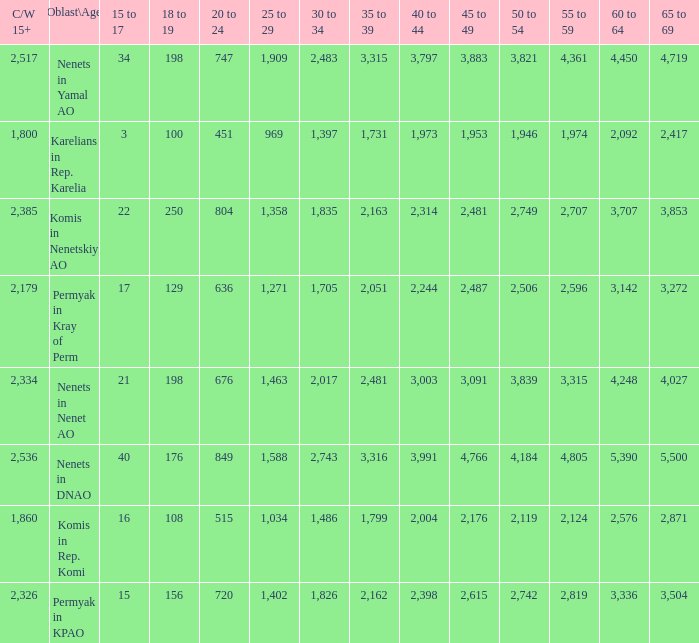Help me parse the entirety of this table. {'header': ['C/W 15+', 'Oblast\\Age', '15 to 17', '18 to 19', '20 to 24', '25 to 29', '30 to 34', '35 to 39', '40 to 44', '45 to 49', '50 to 54', '55 to 59', '60 to 64', '65 to 69'], 'rows': [['2,517', 'Nenets in Yamal AO', '34', '198', '747', '1,909', '2,483', '3,315', '3,797', '3,883', '3,821', '4,361', '4,450', '4,719'], ['1,800', 'Karelians in Rep. Karelia', '3', '100', '451', '969', '1,397', '1,731', '1,973', '1,953', '1,946', '1,974', '2,092', '2,417'], ['2,385', 'Komis in Nenetskiy AO', '22', '250', '804', '1,358', '1,835', '2,163', '2,314', '2,481', '2,749', '2,707', '3,707', '3,853'], ['2,179', 'Permyak in Kray of Perm', '17', '129', '636', '1,271', '1,705', '2,051', '2,244', '2,487', '2,506', '2,596', '3,142', '3,272'], ['2,334', 'Nenets in Nenet AO', '21', '198', '676', '1,463', '2,017', '2,481', '3,003', '3,091', '3,839', '3,315', '4,248', '4,027'], ['2,536', 'Nenets in DNAO', '40', '176', '849', '1,588', '2,743', '3,316', '3,991', '4,766', '4,184', '4,805', '5,390', '5,500'], ['1,860', 'Komis in Rep. Komi', '16', '108', '515', '1,034', '1,486', '1,799', '2,004', '2,176', '2,119', '2,124', '2,576', '2,871'], ['2,326', 'Permyak in KPAO', '15', '156', '720', '1,402', '1,826', '2,162', '2,398', '2,615', '2,742', '2,819', '3,336', '3,504']]} With a 35 to 39 greater than 3,315 what is the 45 to 49? 4766.0. 